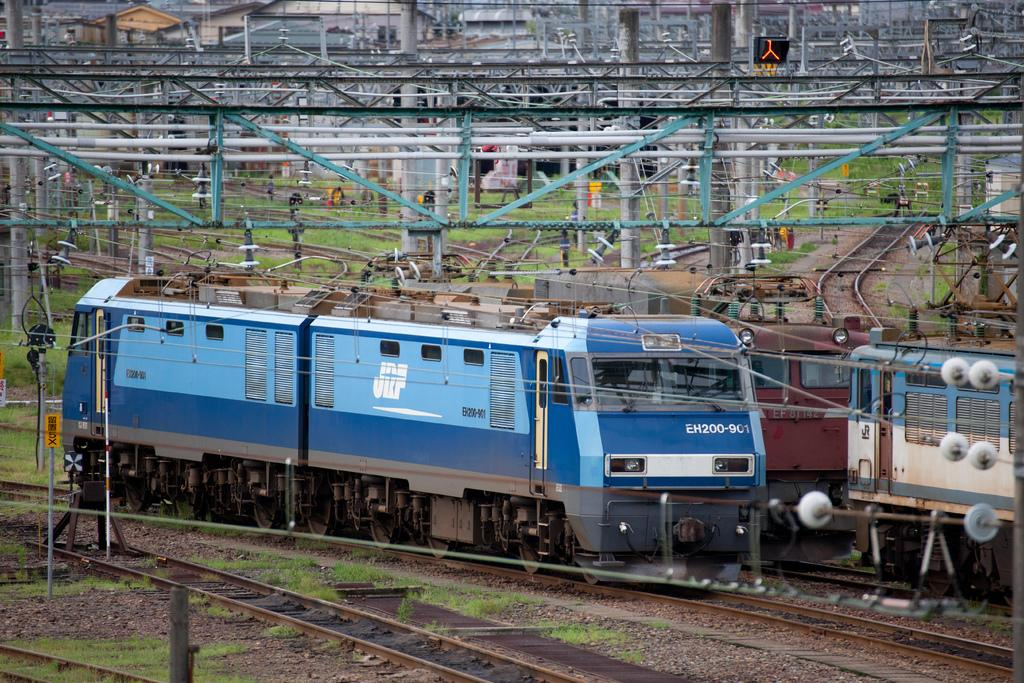Provide a one-sentence caption for the provided image. A railroad train with the numbers EH200-901 on the front. 